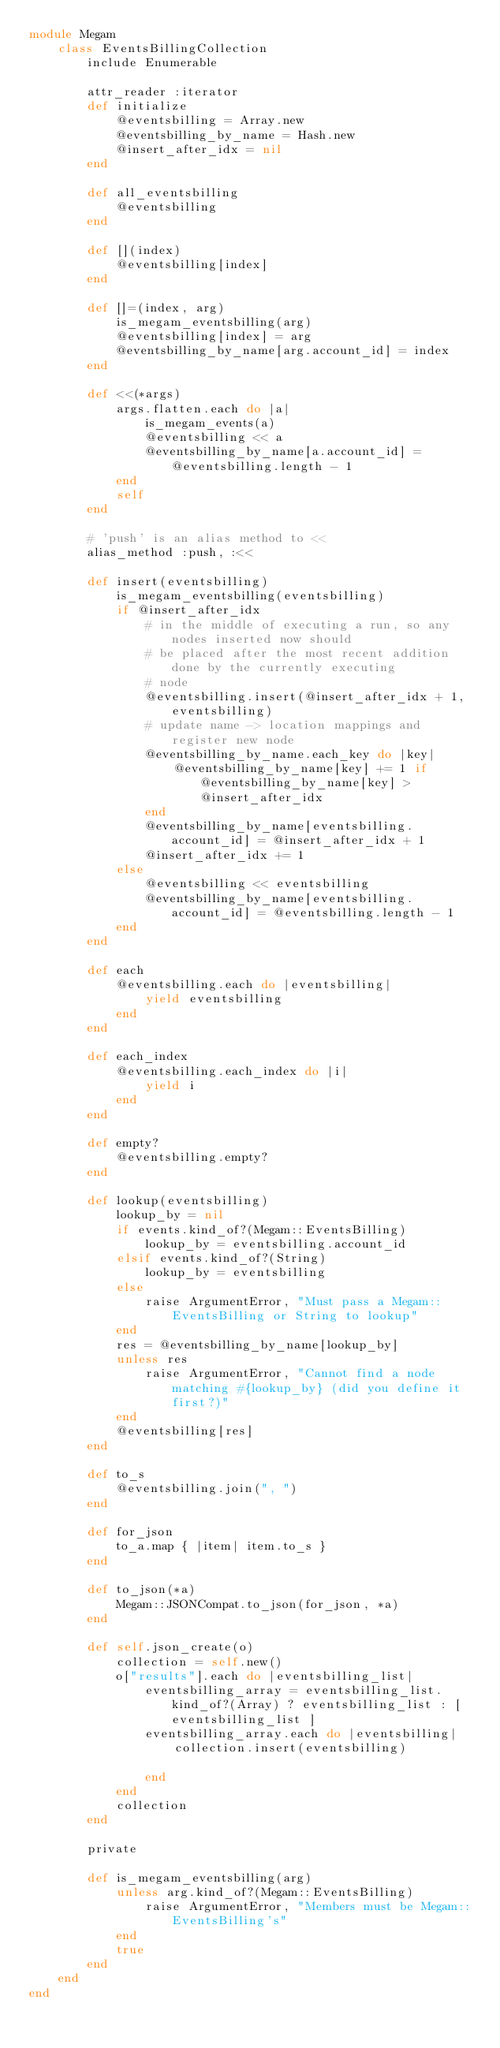Convert code to text. <code><loc_0><loc_0><loc_500><loc_500><_Ruby_>module Megam
    class EventsBillingCollection
        include Enumerable

        attr_reader :iterator
        def initialize
            @eventsbilling = Array.new
            @eventsbilling_by_name = Hash.new
            @insert_after_idx = nil
        end

        def all_eventsbilling
            @eventsbilling
        end

        def [](index)
            @eventsbilling[index]
        end

        def []=(index, arg)
            is_megam_eventsbilling(arg)
            @eventsbilling[index] = arg
            @eventsbilling_by_name[arg.account_id] = index
        end

        def <<(*args)
            args.flatten.each do |a|
                is_megam_events(a)
                @eventsbilling << a
                @eventsbilling_by_name[a.account_id] = @eventsbilling.length - 1
            end
            self
        end

        # 'push' is an alias method to <<
        alias_method :push, :<<

        def insert(eventsbilling)
            is_megam_eventsbilling(eventsbilling)
            if @insert_after_idx
                # in the middle of executing a run, so any nodes inserted now should
                # be placed after the most recent addition done by the currently executing
                # node
                @eventsbilling.insert(@insert_after_idx + 1, eventsbilling)
                # update name -> location mappings and register new node
                @eventsbilling_by_name.each_key do |key|
                    @eventsbilling_by_name[key] += 1 if @eventsbilling_by_name[key] > @insert_after_idx
                end
                @eventsbilling_by_name[eventsbilling.account_id] = @insert_after_idx + 1
                @insert_after_idx += 1
            else
                @eventsbilling << eventsbilling
                @eventsbilling_by_name[eventsbilling.account_id] = @eventsbilling.length - 1
            end
        end

        def each
            @eventsbilling.each do |eventsbilling|
                yield eventsbilling
            end
        end

        def each_index
            @eventsbilling.each_index do |i|
                yield i
            end
        end

        def empty?
            @eventsbilling.empty?
        end

        def lookup(eventsbilling)
            lookup_by = nil
            if events.kind_of?(Megam::EventsBilling)
                lookup_by = eventsbilling.account_id
            elsif events.kind_of?(String)
                lookup_by = eventsbilling
            else
                raise ArgumentError, "Must pass a Megam::EventsBilling or String to lookup"
            end
            res = @eventsbilling_by_name[lookup_by]
            unless res
                raise ArgumentError, "Cannot find a node matching #{lookup_by} (did you define it first?)"
            end
            @eventsbilling[res]
        end

        def to_s
            @eventsbilling.join(", ")
        end

        def for_json
            to_a.map { |item| item.to_s }
        end

        def to_json(*a)
            Megam::JSONCompat.to_json(for_json, *a)
        end

        def self.json_create(o)
            collection = self.new()
            o["results"].each do |eventsbilling_list|
                eventsbilling_array = eventsbilling_list.kind_of?(Array) ? eventsbilling_list : [ eventsbilling_list ]
                eventsbilling_array.each do |eventsbilling|
                    collection.insert(eventsbilling)

                end
            end
            collection
        end

        private

        def is_megam_eventsbilling(arg)
            unless arg.kind_of?(Megam::EventsBilling)
                raise ArgumentError, "Members must be Megam::EventsBilling's"
            end
            true
        end
    end
end
</code> 